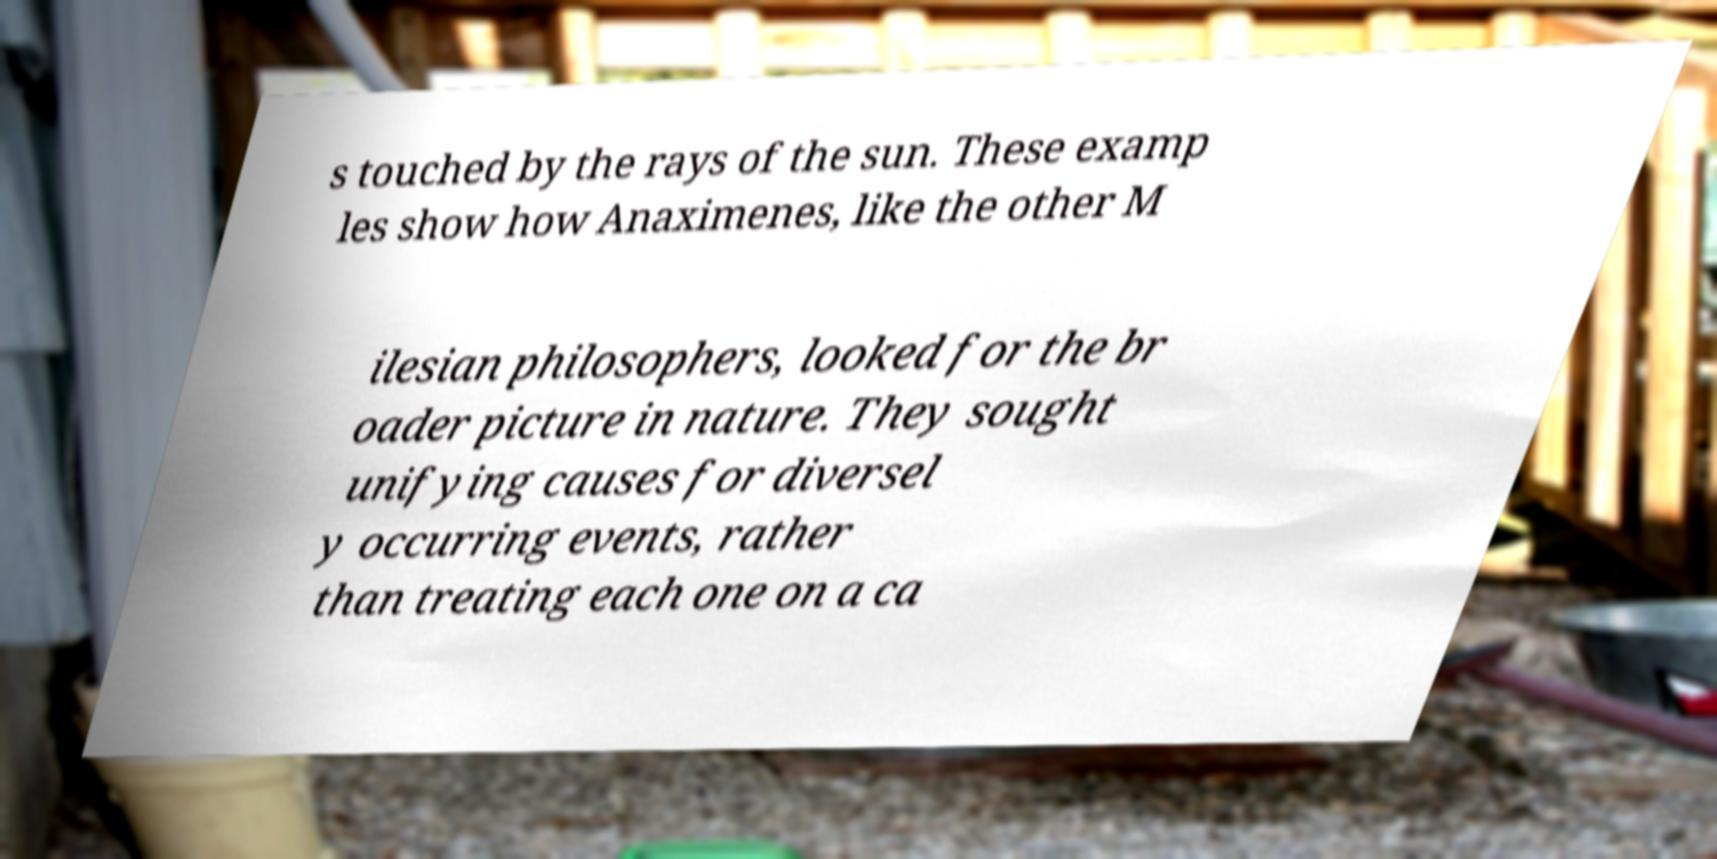I need the written content from this picture converted into text. Can you do that? s touched by the rays of the sun. These examp les show how Anaximenes, like the other M ilesian philosophers, looked for the br oader picture in nature. They sought unifying causes for diversel y occurring events, rather than treating each one on a ca 